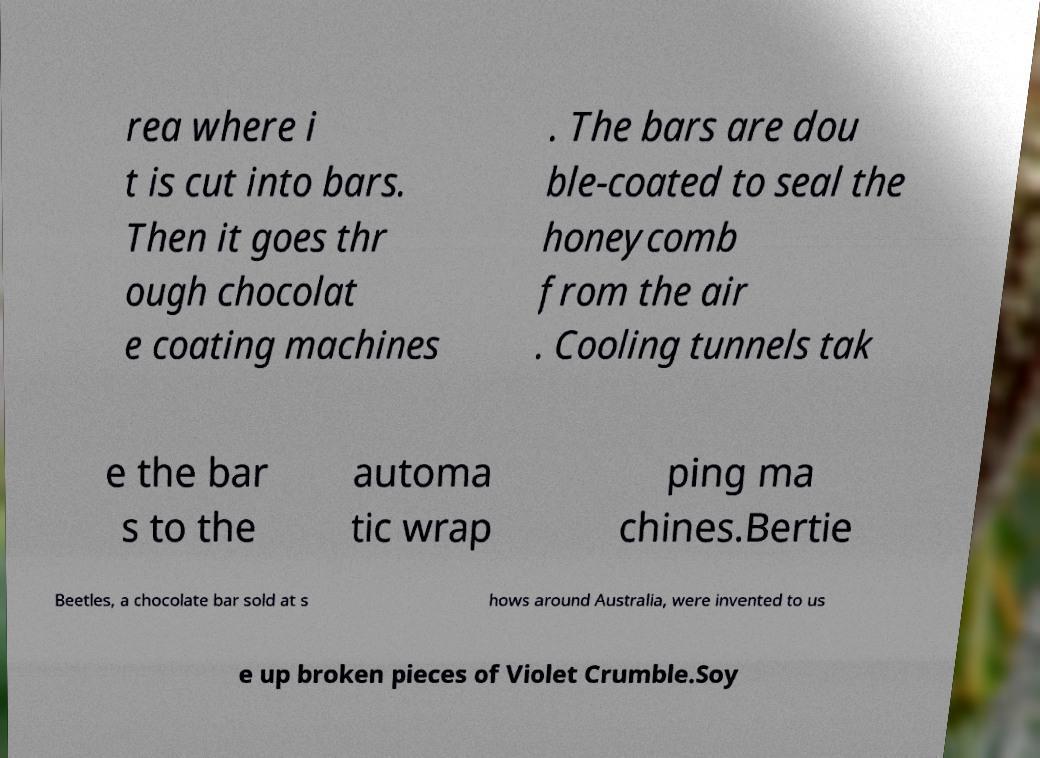Could you extract and type out the text from this image? rea where i t is cut into bars. Then it goes thr ough chocolat e coating machines . The bars are dou ble-coated to seal the honeycomb from the air . Cooling tunnels tak e the bar s to the automa tic wrap ping ma chines.Bertie Beetles, a chocolate bar sold at s hows around Australia, were invented to us e up broken pieces of Violet Crumble.Soy 